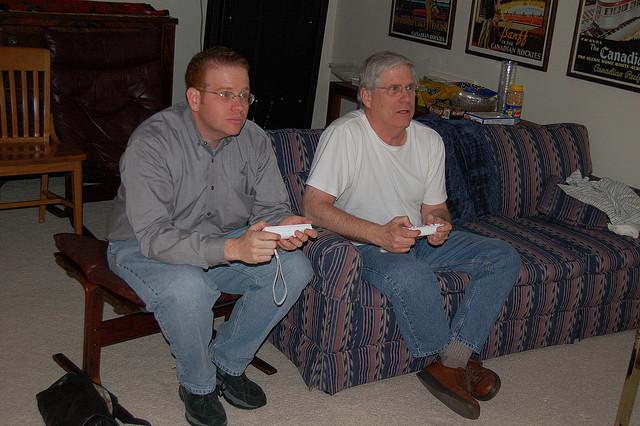Are these children or adults?
Be succinct. Adults. Is the man wearing shoes?
Be succinct. Yes. Where is this picture taken?
Be succinct. Living room. Are there children in the picture?
Answer briefly. No. Is the wall freshly painted?
Quick response, please. No. Where is the man's luggage?
Quick response, please. Closet. Are they happy?
Answer briefly. Yes. Are these men playing an Xbox?
Answer briefly. No. Are they all wearing blue jeans?
Be succinct. Yes. What is he doing?
Quick response, please. Playing wii. What's in the middle of room?
Answer briefly. Couch. Are the people playing or standing?
Short answer required. Playing. What pattern is on the couch?
Be succinct. Stripes. How many fingers is the man on the left holding up?
Give a very brief answer. 0. Do they appear to be having fun?
Quick response, please. Yes. How many cowboy hats?
Keep it brief. 0. How many people are playing?
Write a very short answer. 2. Are the people most likely veterinarians?
Quick response, please. No. Is the man sitting on the bench?
Short answer required. Yes. Do these men look tired?
Give a very brief answer. No. What object is being held with both hands?
Write a very short answer. Wii controller. What color are the men's shoes?
Short answer required. Black and brown. Are the color of their shirts the same?
Keep it brief. No. What is on the person's feet?
Be succinct. Shoes. How many men are in this image?
Concise answer only. 2. What type of shoes is he wearing?
Give a very brief answer. Tennis shoes. Are these men happy?
Keep it brief. Yes. Did they grow up with that toy?
Be succinct. No. What is on the feet?
Concise answer only. Shoes. What color is the boys hat?
Answer briefly. No hat. Are the two brothers?
Be succinct. No. Is someone taking a picture?
Quick response, please. No. What console are they playing?
Short answer required. Wii. How many are wearing glasses?
Write a very short answer. 2. What color is the mans cup?
Give a very brief answer. Clear. What is held in the man's lap in the photograph?
Keep it brief. Wii controller. Are the men in the photo looking up?
Be succinct. No. How many bean bag chairs are in this photo?
Short answer required. 0. Where is the picture taken at?
Answer briefly. Living room. What is the man holding?
Keep it brief. Controller. Are they going on a trip?
Concise answer only. No. Why are they sitting on the ground?
Be succinct. Playing game. Do you think these two persons had a little too much to drink?
Be succinct. No. How many people?
Keep it brief. 2. What color is the man's shirt?
Keep it brief. White. What color are the shoes?
Give a very brief answer. Brown. Are they at an adult party?
Short answer required. No. Are the mean wearing formal wear?
Give a very brief answer. No. What are the men touching?
Give a very brief answer. Wii controllers. Is the man using his cell phone?
Short answer required. No. 